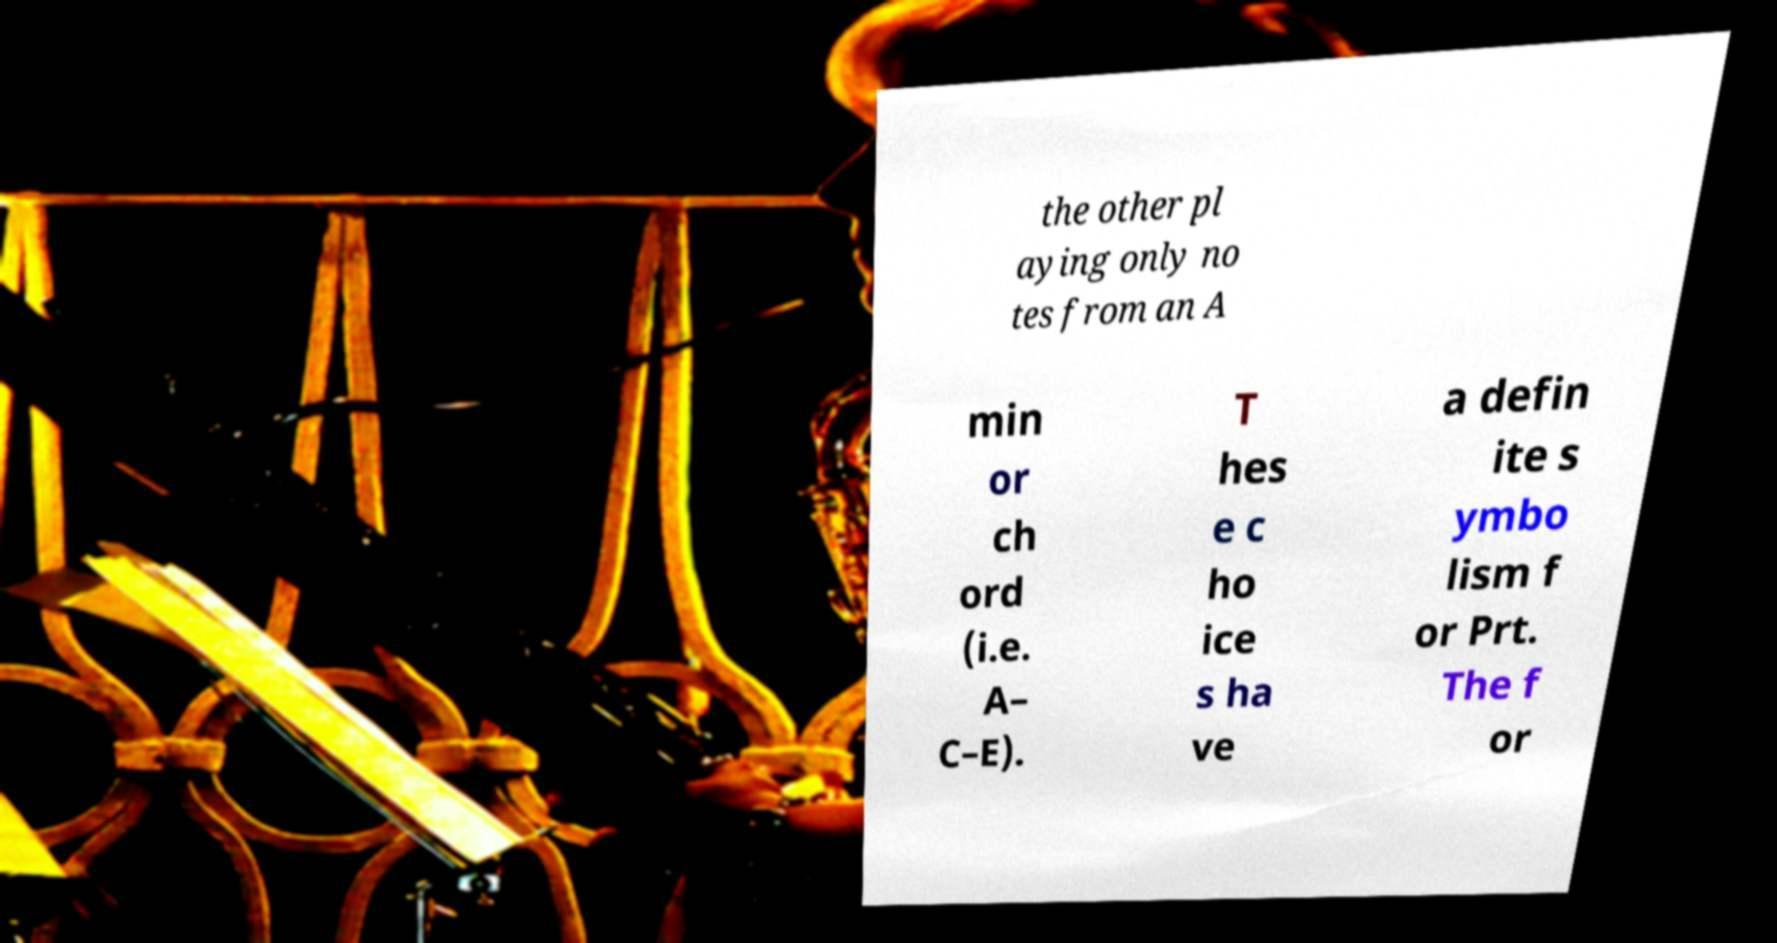What messages or text are displayed in this image? I need them in a readable, typed format. the other pl aying only no tes from an A min or ch ord (i.e. A– C–E). T hes e c ho ice s ha ve a defin ite s ymbo lism f or Prt. The f or 